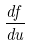Convert formula to latex. <formula><loc_0><loc_0><loc_500><loc_500>\frac { d f } { d u }</formula> 